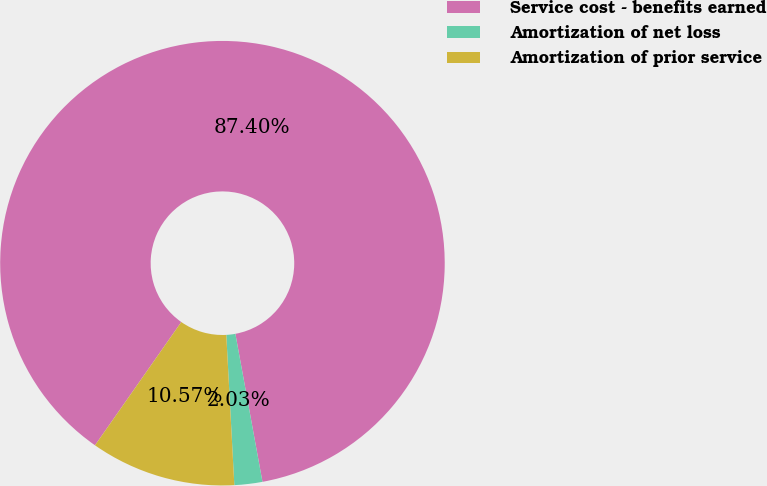<chart> <loc_0><loc_0><loc_500><loc_500><pie_chart><fcel>Service cost - benefits earned<fcel>Amortization of net loss<fcel>Amortization of prior service<nl><fcel>87.4%<fcel>2.03%<fcel>10.57%<nl></chart> 